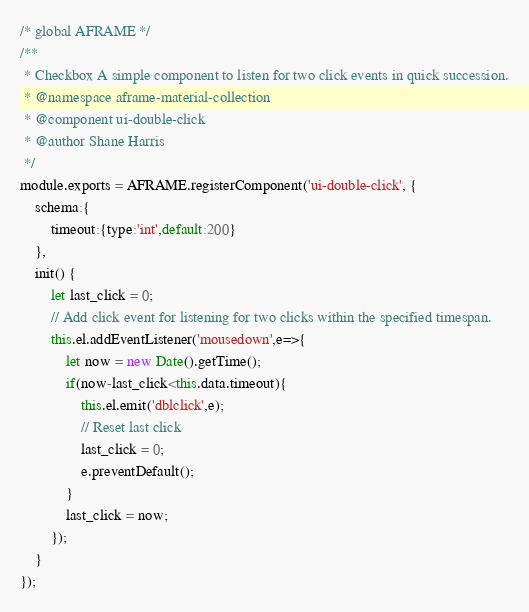Convert code to text. <code><loc_0><loc_0><loc_500><loc_500><_JavaScript_>/* global AFRAME */
/**
 * Checkbox A simple component to listen for two click events in quick succession.
 * @namespace aframe-material-collection
 * @component ui-double-click
 * @author Shane Harris
 */
module.exports = AFRAME.registerComponent('ui-double-click', {
    schema:{
        timeout:{type:'int',default:200}
    },
    init() {
        let last_click = 0;
        // Add click event for listening for two clicks within the specified timespan.
        this.el.addEventListener('mousedown',e=>{
            let now = new Date().getTime();
            if(now-last_click<this.data.timeout){
                this.el.emit('dblclick',e);
                // Reset last click
                last_click = 0;
                e.preventDefault();
            }
            last_click = now;
        });
    }
});</code> 